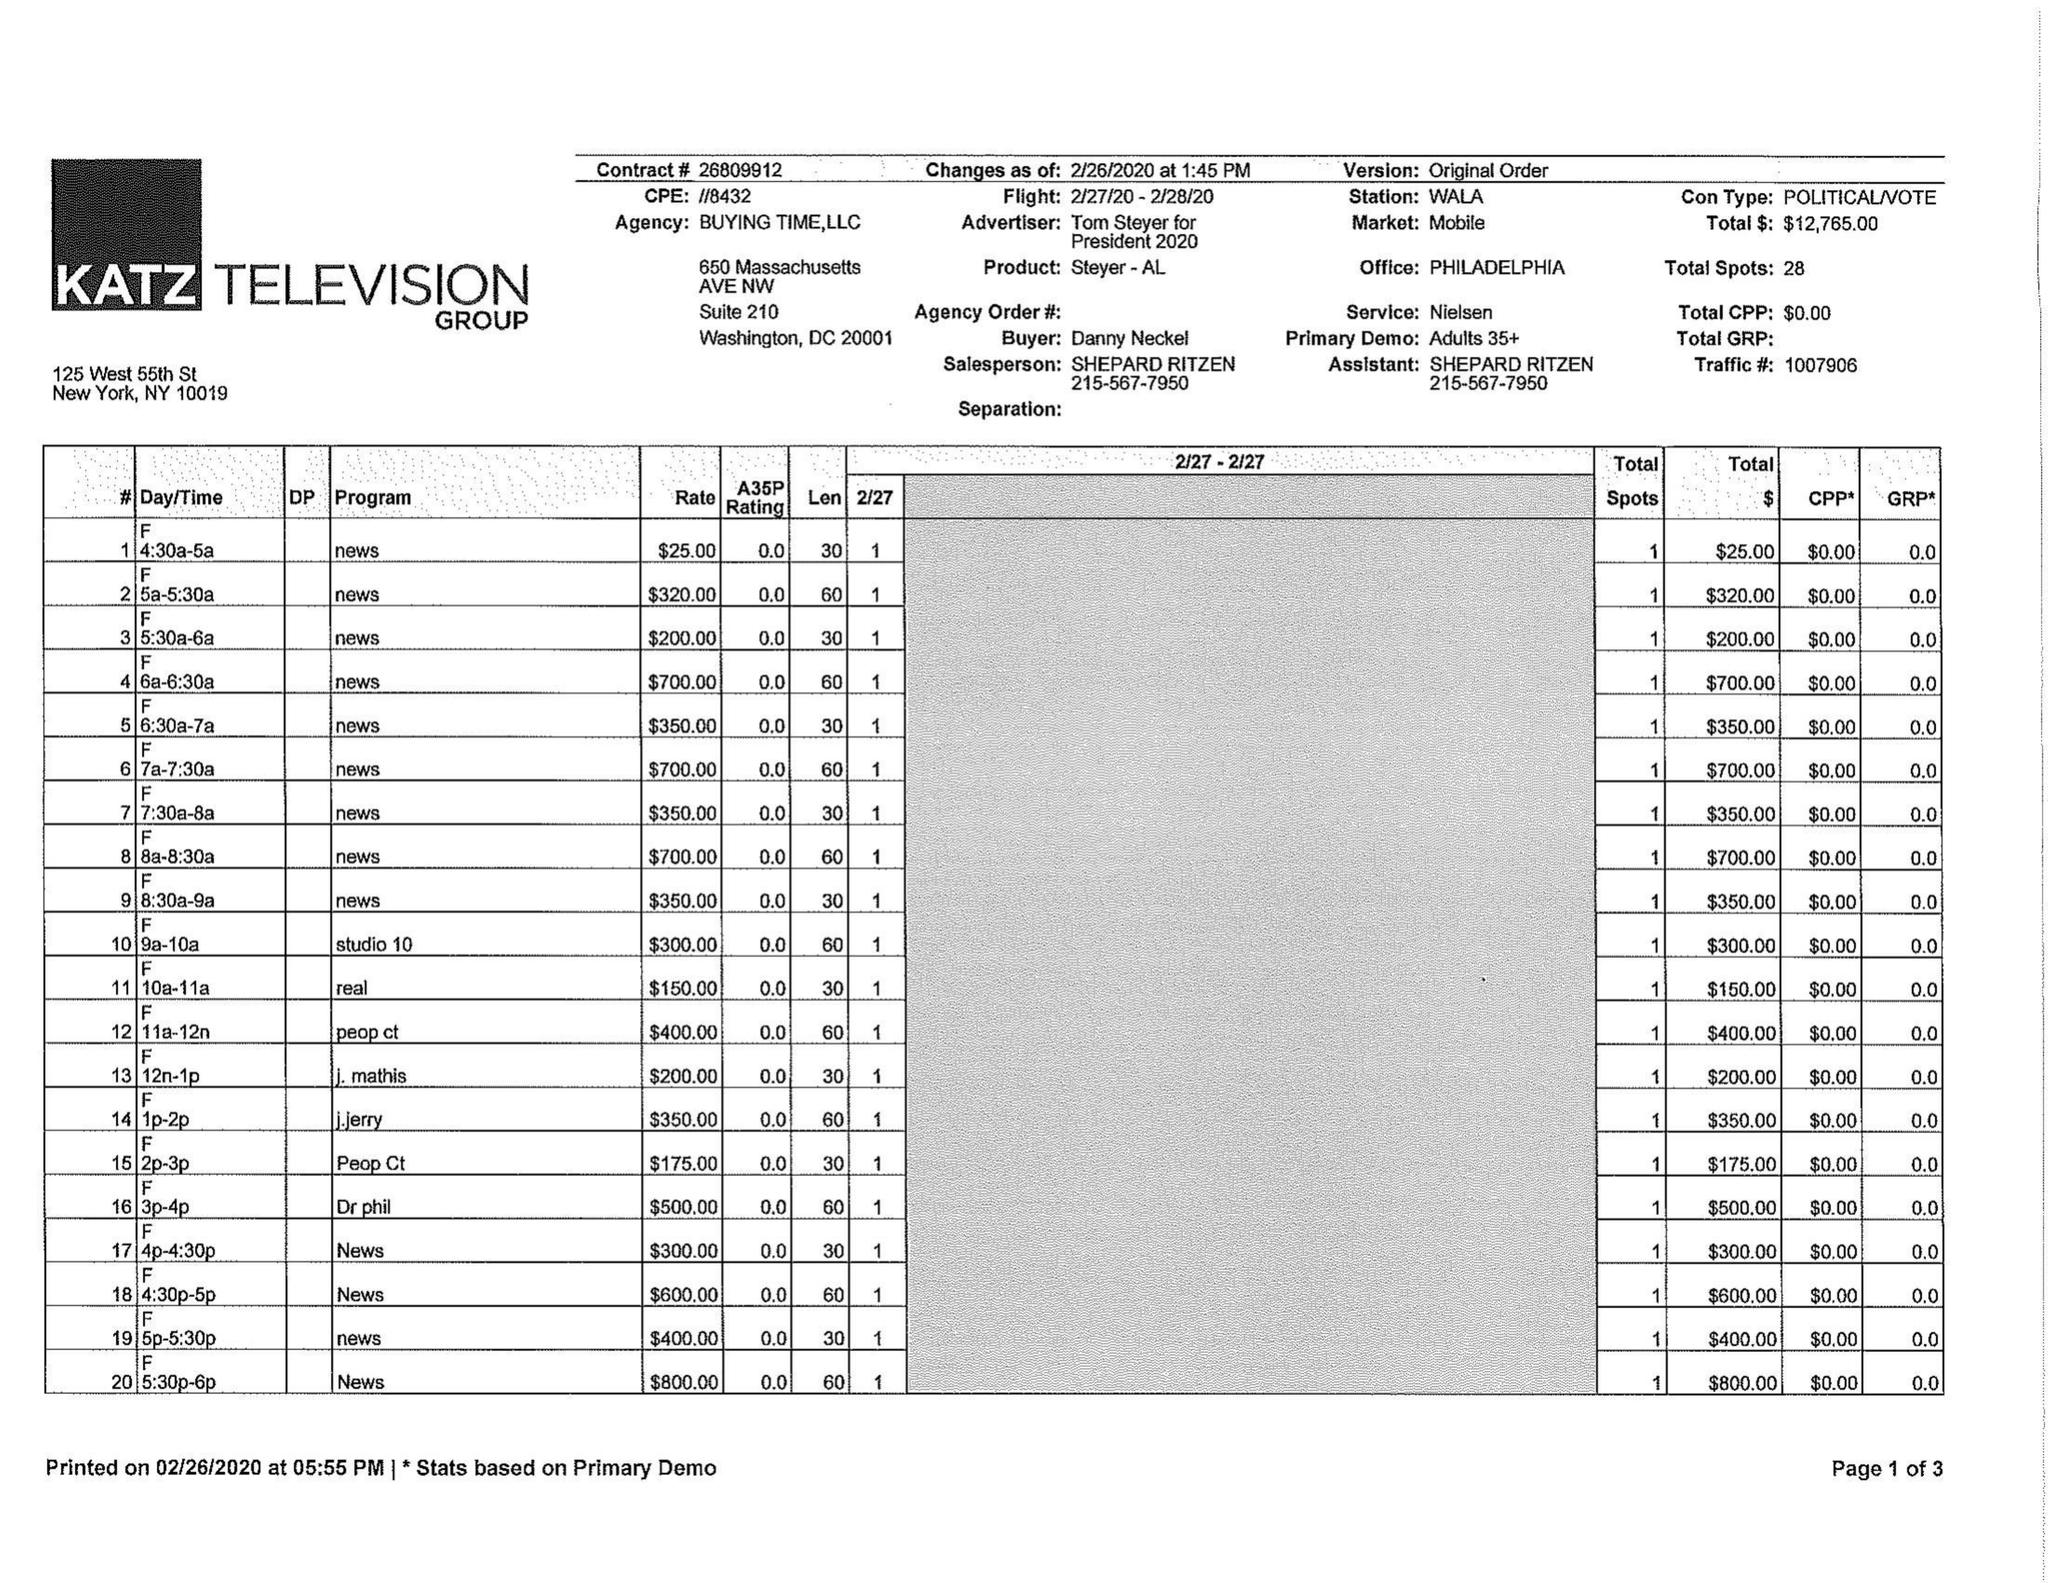What is the value for the contract_num?
Answer the question using a single word or phrase. 26809912 